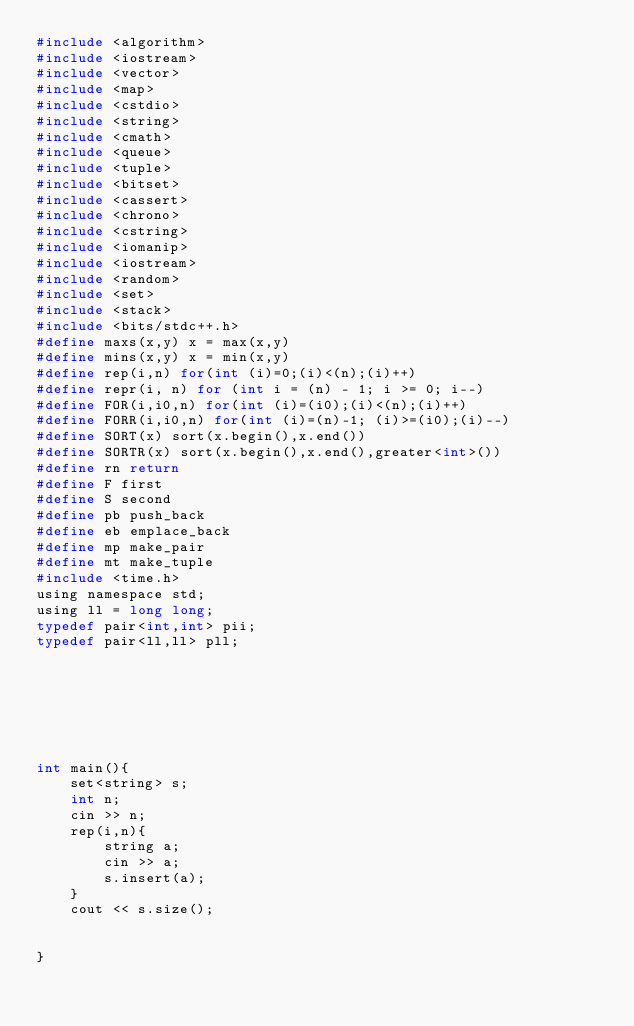Convert code to text. <code><loc_0><loc_0><loc_500><loc_500><_C_>#include <algorithm>
#include <iostream>
#include <vector>
#include <map>
#include <cstdio>
#include <string>
#include <cmath>
#include <queue>
#include <tuple>
#include <bitset>
#include <cassert>
#include <chrono>
#include <cstring>
#include <iomanip>
#include <iostream>
#include <random>
#include <set>
#include <stack>
#include <bits/stdc++.h>
#define maxs(x,y) x = max(x,y)
#define mins(x,y) x = min(x,y)
#define rep(i,n) for(int (i)=0;(i)<(n);(i)++)
#define repr(i, n) for (int i = (n) - 1; i >= 0; i--)
#define FOR(i,i0,n) for(int (i)=(i0);(i)<(n);(i)++)
#define FORR(i,i0,n) for(int (i)=(n)-1; (i)>=(i0);(i)--)
#define SORT(x) sort(x.begin(),x.end())
#define SORTR(x) sort(x.begin(),x.end(),greater<int>())
#define rn return
#define F first
#define S second
#define pb push_back
#define eb emplace_back
#define mp make_pair
#define mt make_tuple
#include <time.h>
using namespace std;
using ll = long long;
typedef pair<int,int> pii;
typedef pair<ll,ll> pll;







int main(){
    set<string> s;
    int n;
    cin >> n;
    rep(i,n){
        string a;
        cin >> a;
        s.insert(a);
    }
    cout << s.size();
    

}







</code> 